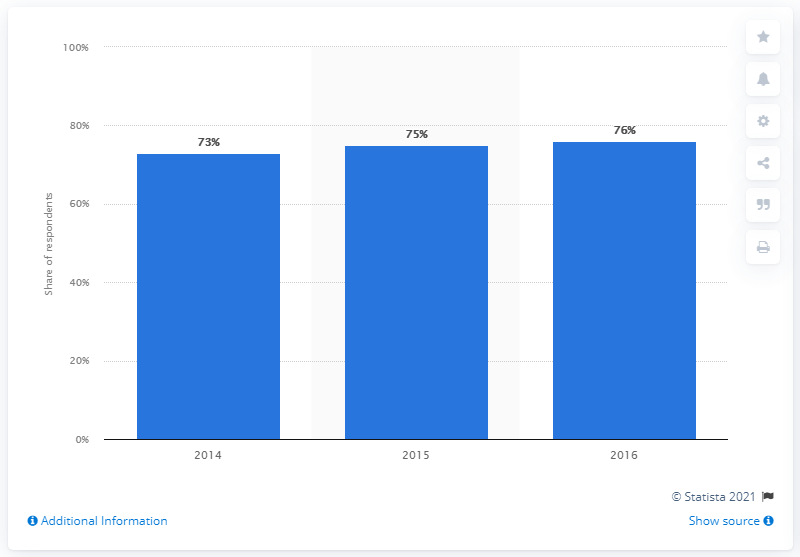Draw attention to some important aspects in this diagram. The survey asked homeowners in 2016 if they had any home improvement plans. 